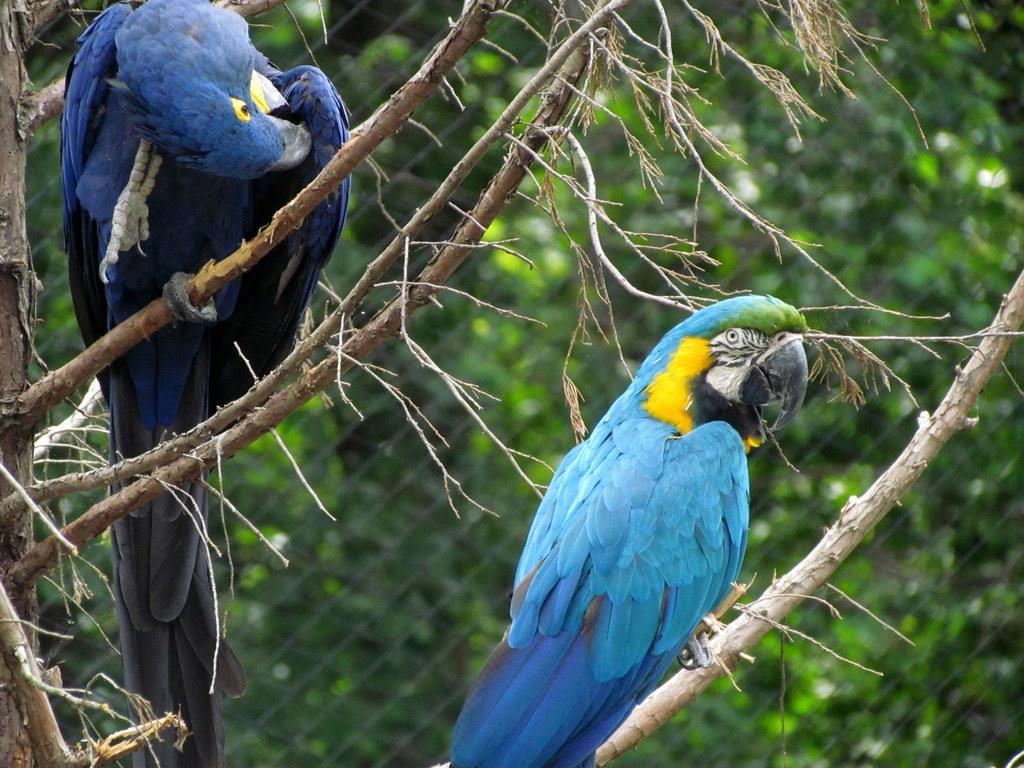What type of bird is in the image? There is a blue parrot in the image. Where is the blue parrot located? The blue parrot is sitting on a tree branch. Are there any other birds in the image? Yes, there is another parrot in the image. What color is the second parrot? The second parrot is dark blue in color. What type of curtain can be seen hanging from the tree branch in the image? There is no curtain present in the image; it features two parrots sitting on a tree branch. 